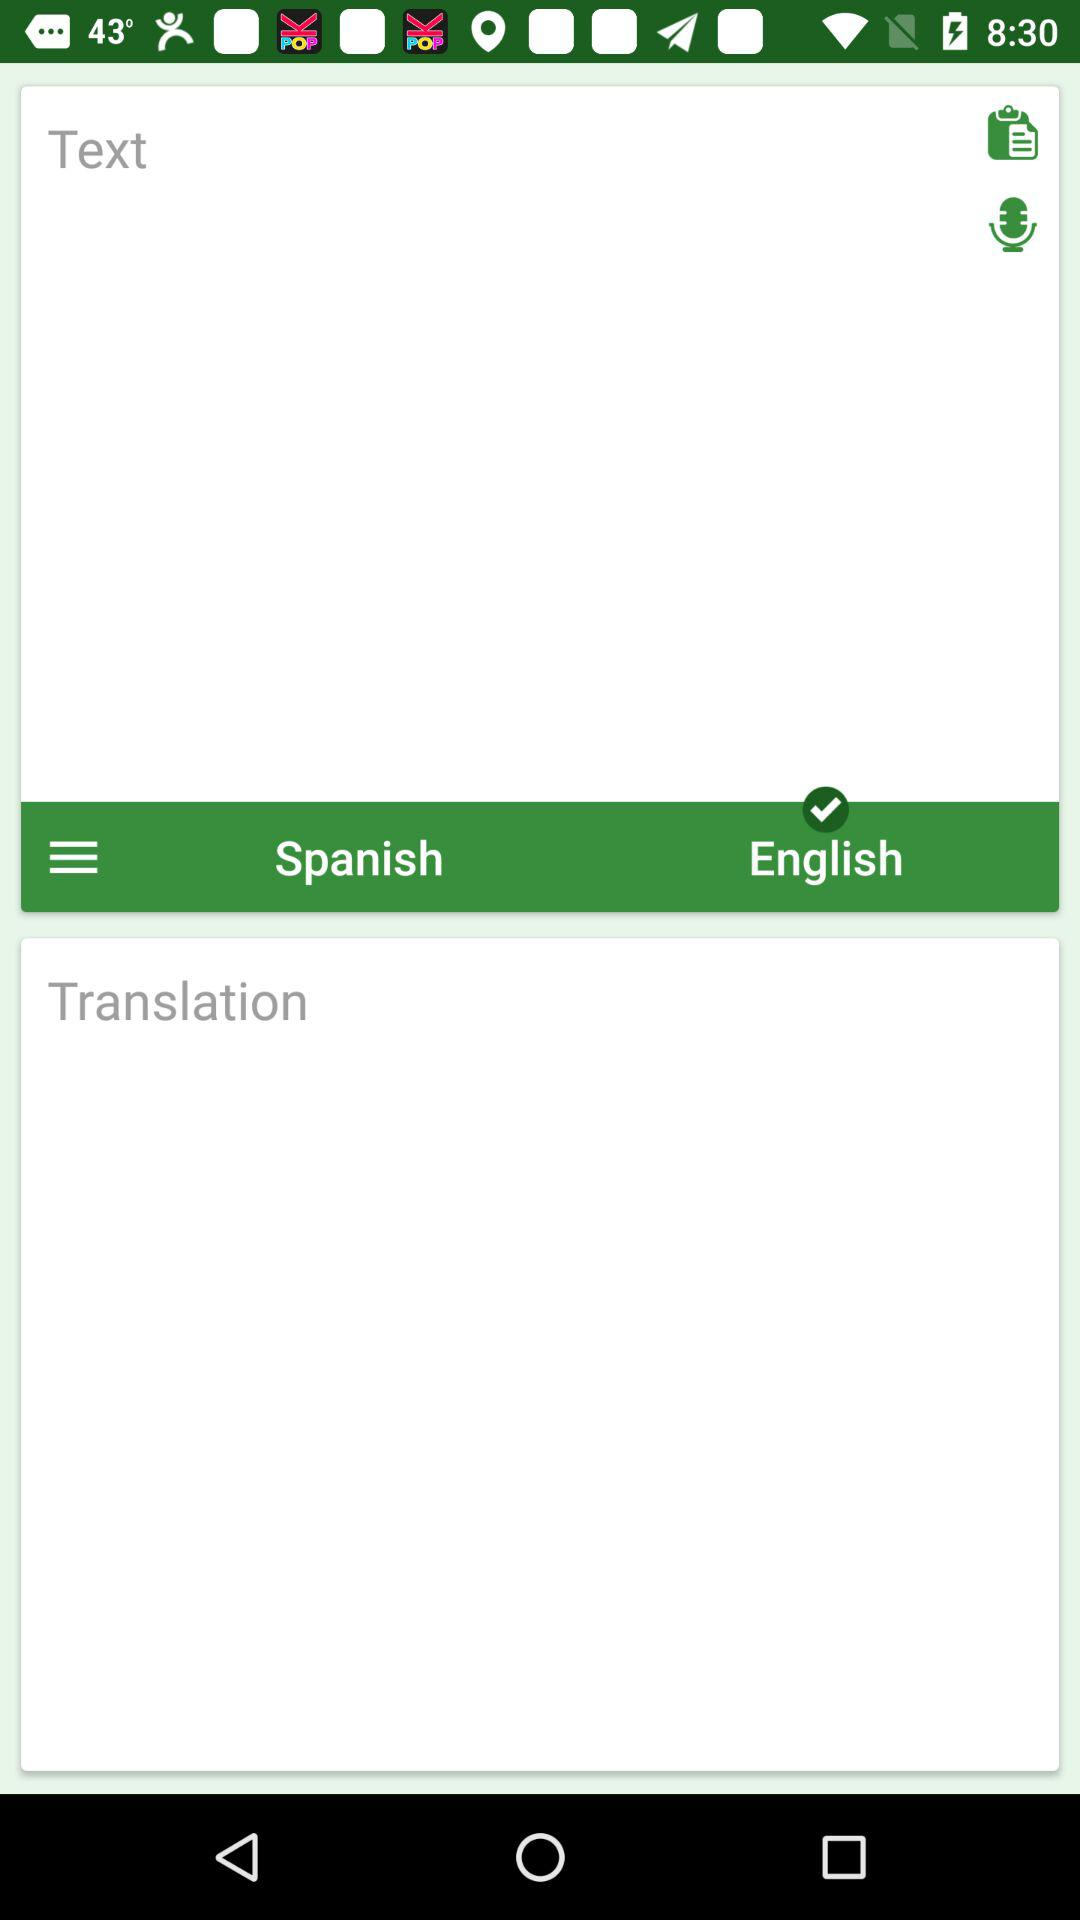Which language is selected for translation? The language selected for translation is English. 